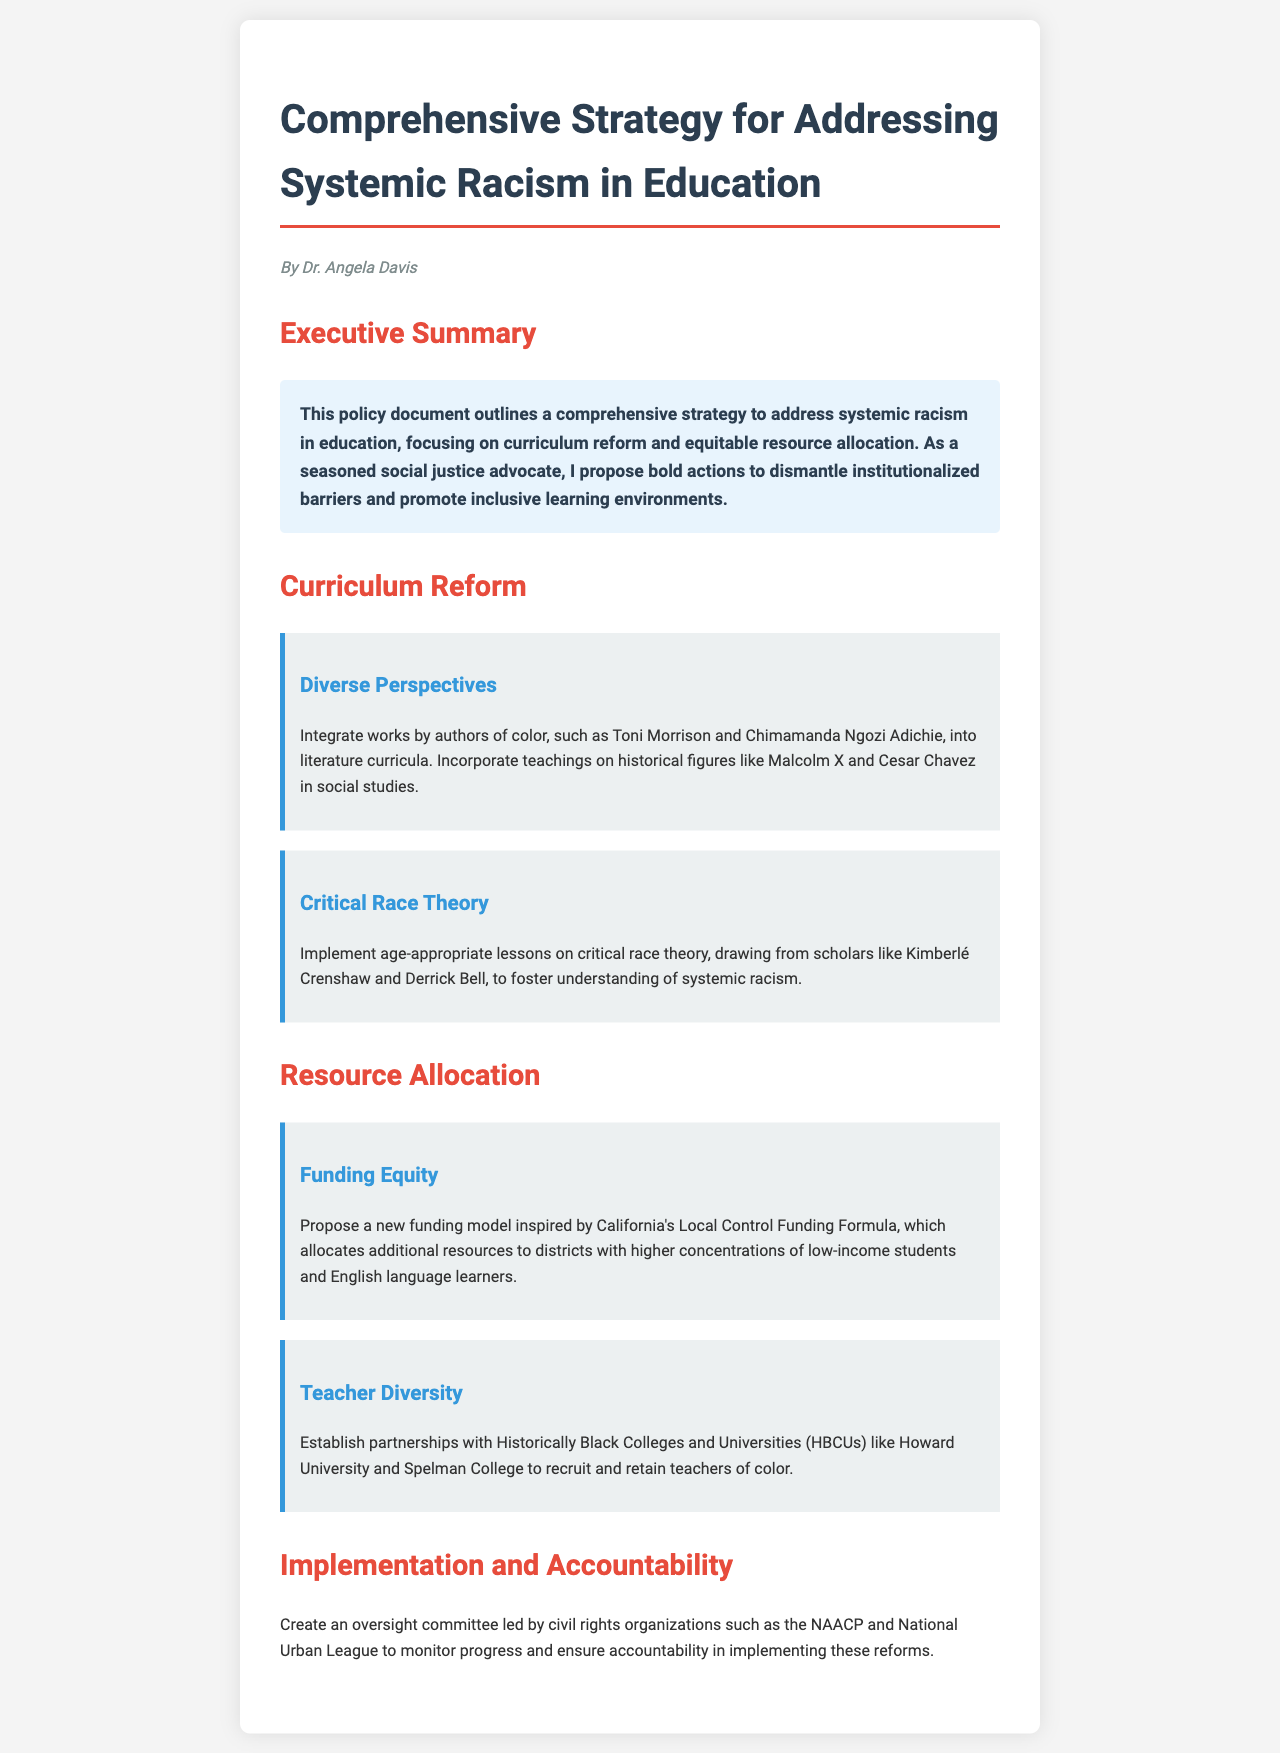What is the title of the document? The title of the document is provided at the beginning, indicating the focus on systemic racism in education.
Answer: Comprehensive Strategy for Addressing Systemic Racism in Education Who authored the document? The author of the document is mentioned below the title, which attributes the content to a specific individual.
Answer: Dr. Angela Davis What is the main focus of the document? The main focus is highlighted in the executive summary section, illustrating the purpose and objective of the policy.
Answer: Curriculum reform and equitable resource allocation Which authors of color are recommended for literature curricula? This specific recommendation is outlined in the curriculum reform section, emphasizing the integration of diverse perspectives.
Answer: Toni Morrison and Chimamanda Ngozi Adichie What new funding model is proposed? The document discusses a specific funding model as part of the resource allocation section to address equity in funding.
Answer: California's Local Control Funding Formula What type of committee is suggested for oversight? The document proposes a specific type of committee for overseeing the implementation of the reforms discussed.
Answer: Oversight committee Which organizations are mentioned for monitoring progress? The document specifies civil rights organizations responsible for ensuring accountability in the document's implementation.
Answer: NAACP and National Urban League What teaching method is proposed to understand systemic racism? The curriculum section suggests an educational approach focused on understanding systemic racism through a specific theory.
Answer: Critical race theory How many sections are there in the document? The document is divided into multiple sections, indicating the structure of the content presented.
Answer: Four sections 